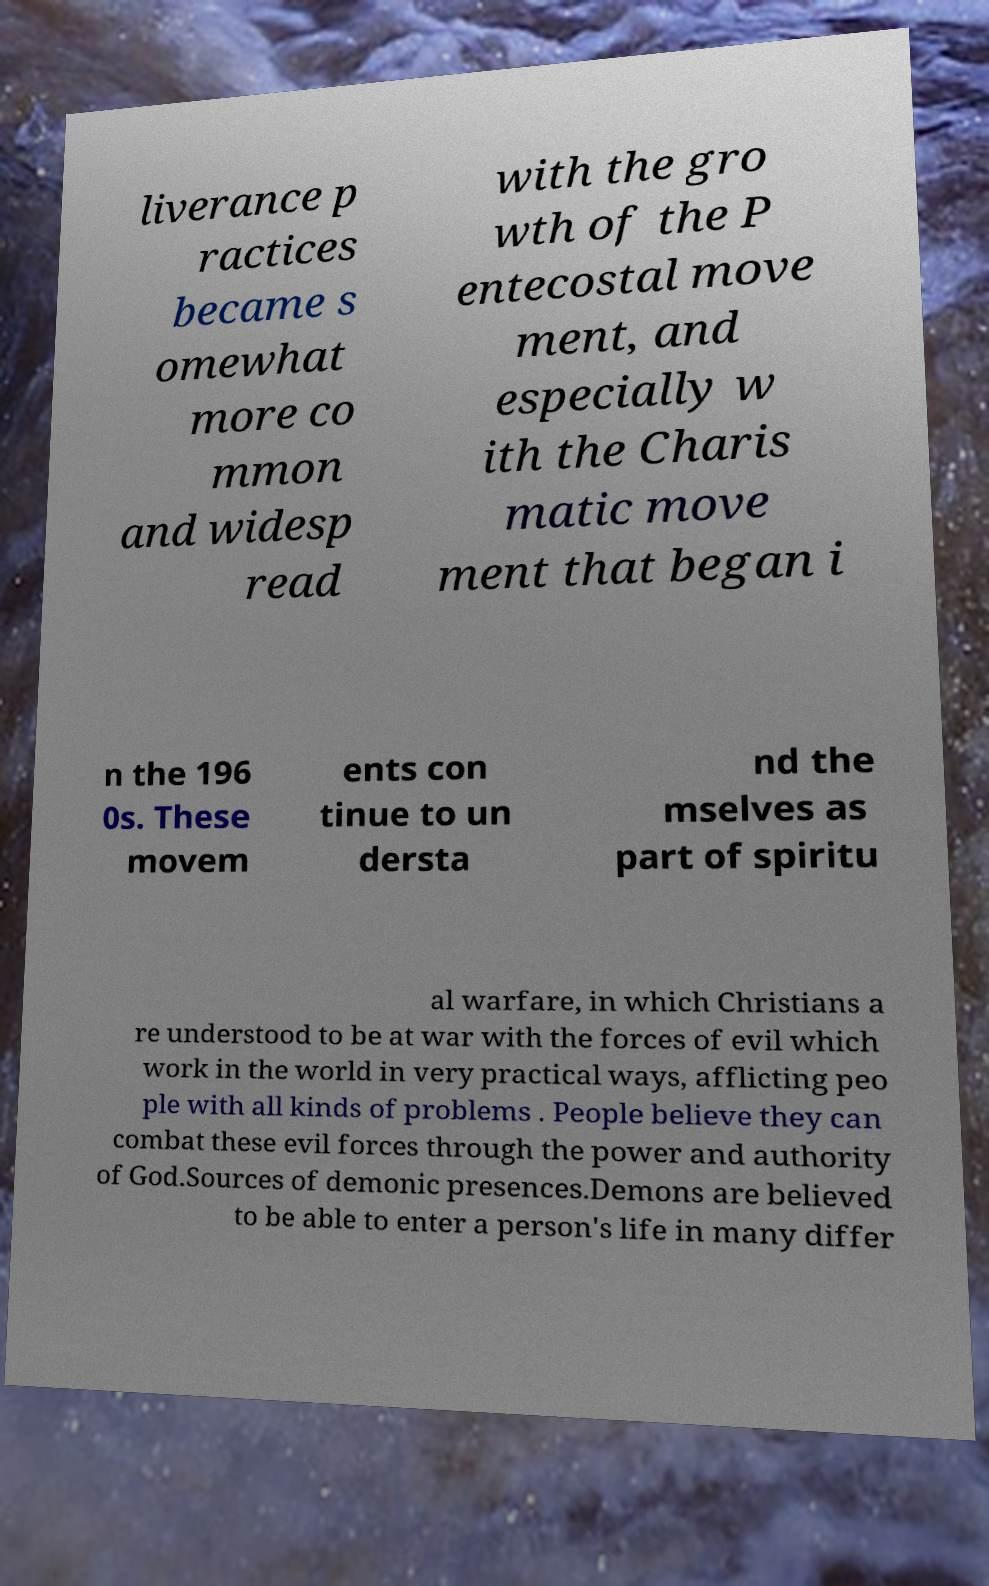Please read and relay the text visible in this image. What does it say? liverance p ractices became s omewhat more co mmon and widesp read with the gro wth of the P entecostal move ment, and especially w ith the Charis matic move ment that began i n the 196 0s. These movem ents con tinue to un dersta nd the mselves as part of spiritu al warfare, in which Christians a re understood to be at war with the forces of evil which work in the world in very practical ways, afflicting peo ple with all kinds of problems . People believe they can combat these evil forces through the power and authority of God.Sources of demonic presences.Demons are believed to be able to enter a person's life in many differ 